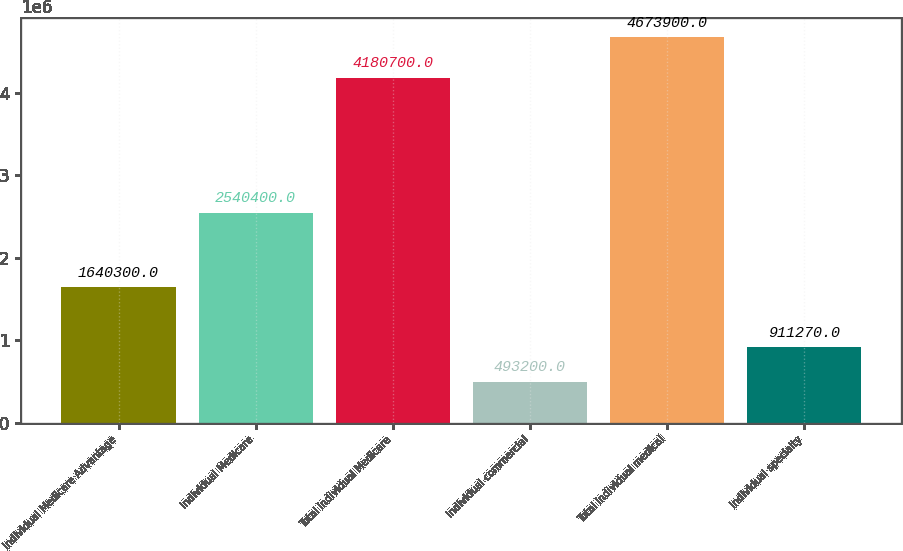<chart> <loc_0><loc_0><loc_500><loc_500><bar_chart><fcel>Individual Medicare Advantage<fcel>Individual Medicare<fcel>Total individual Medicare<fcel>Individual commercial<fcel>Total individual medical<fcel>Individual specialty<nl><fcel>1.6403e+06<fcel>2.5404e+06<fcel>4.1807e+06<fcel>493200<fcel>4.6739e+06<fcel>911270<nl></chart> 